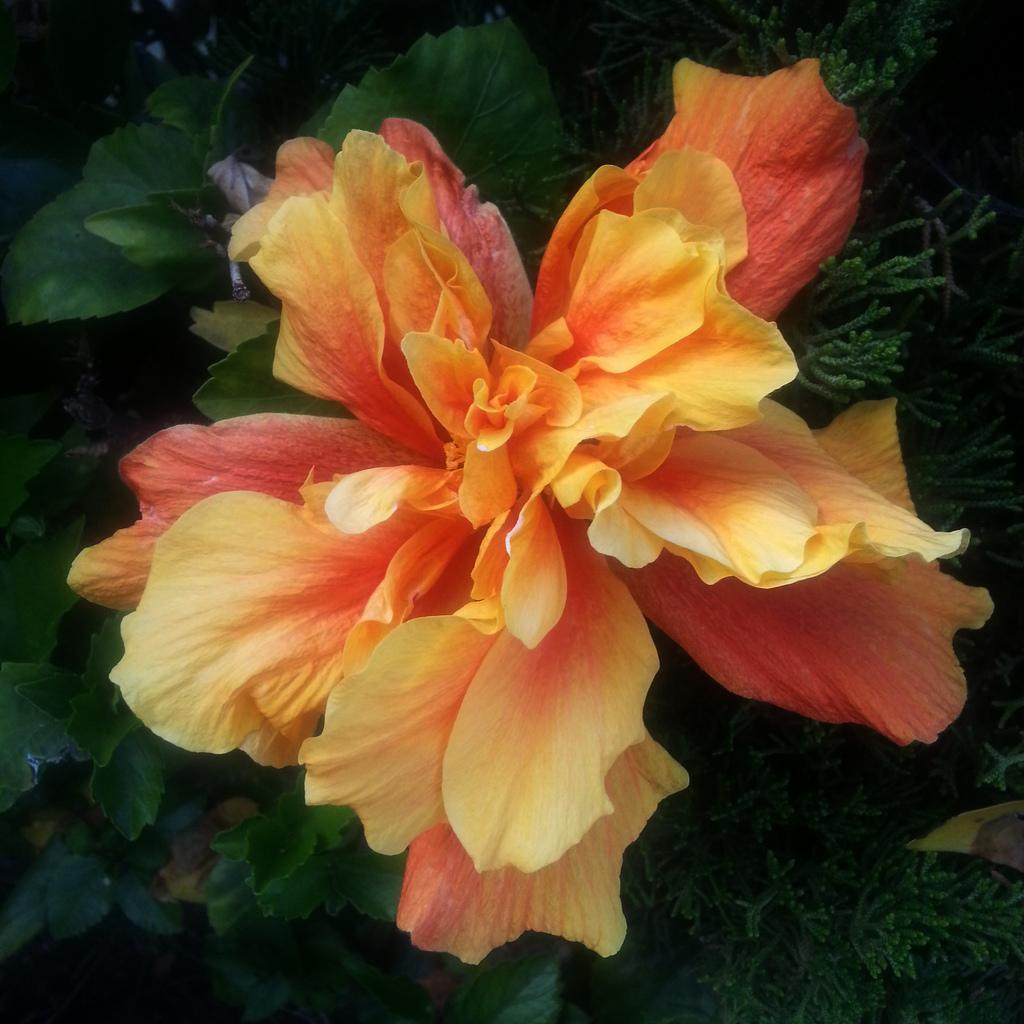What type of plant can be seen in the image? There is a flower in the image. What other part of the plant is visible in the image? There are leaves in the image. What type of beef is being served on the chessboard in the image? There is no beef or chessboard present in the image; it only features a flower and leaves. Can you tell me how many grandfathers are playing chess with the flower in the image? There are no grandfathers or chess games present in the image; it only features a flower and leaves. 